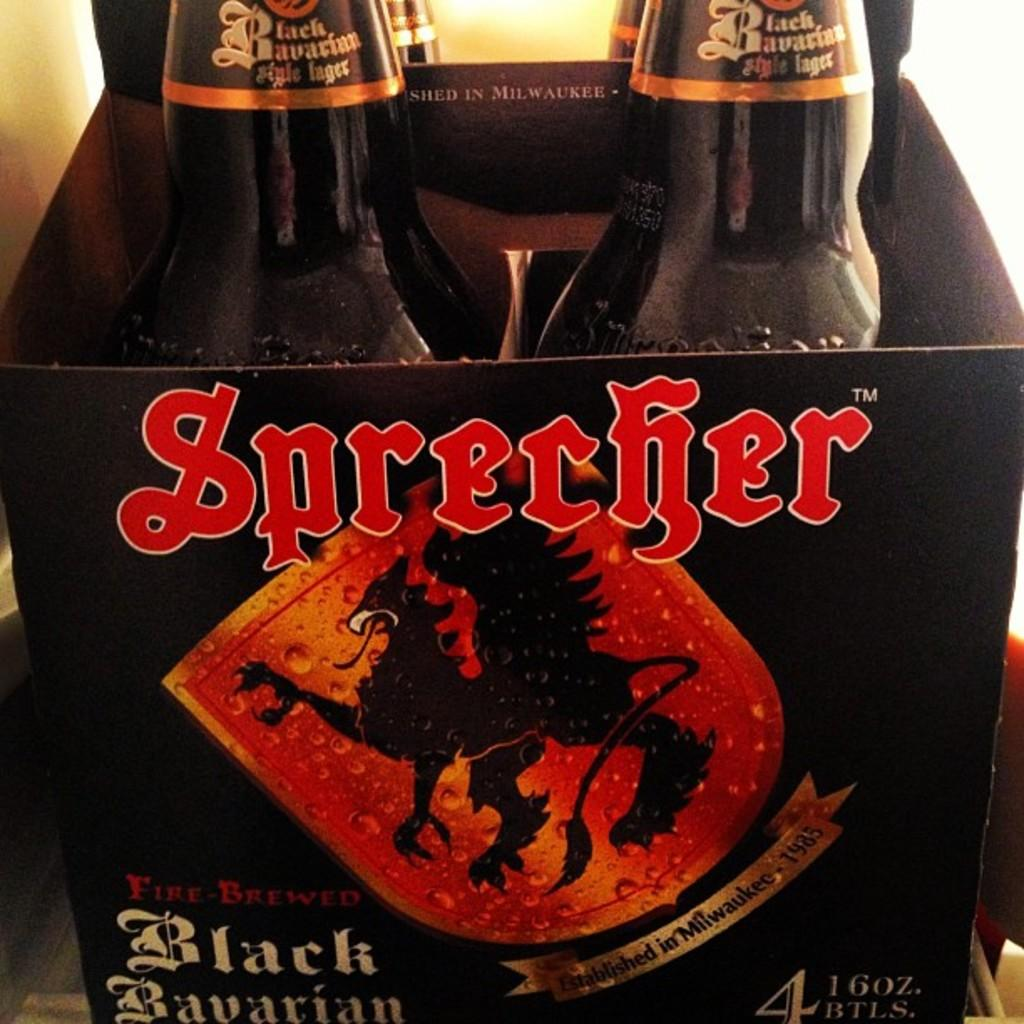<image>
Provide a brief description of the given image. a close up of Sprecher 4 pack of beer 